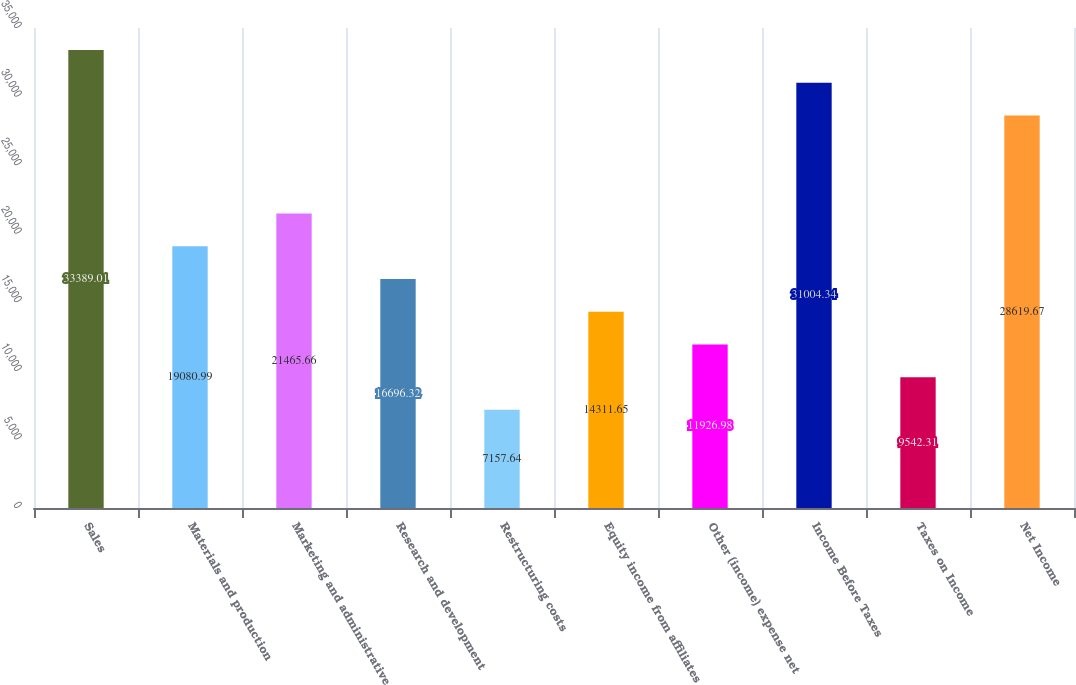Convert chart. <chart><loc_0><loc_0><loc_500><loc_500><bar_chart><fcel>Sales<fcel>Materials and production<fcel>Marketing and administrative<fcel>Research and development<fcel>Restructuring costs<fcel>Equity income from affiliates<fcel>Other (income) expense net<fcel>Income Before Taxes<fcel>Taxes on Income<fcel>Net Income<nl><fcel>33389<fcel>19081<fcel>21465.7<fcel>16696.3<fcel>7157.64<fcel>14311.6<fcel>11927<fcel>31004.3<fcel>9542.31<fcel>28619.7<nl></chart> 